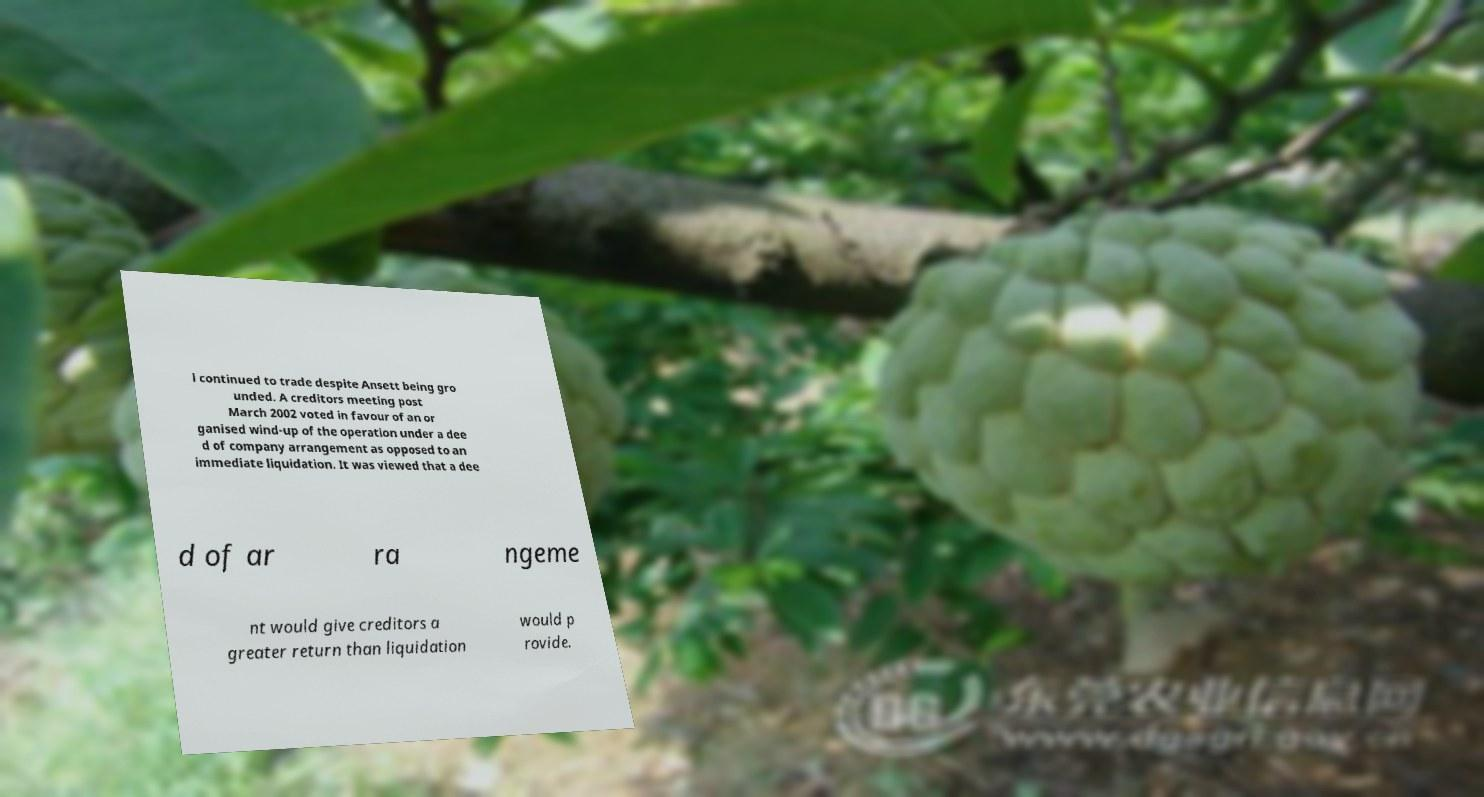For documentation purposes, I need the text within this image transcribed. Could you provide that? l continued to trade despite Ansett being gro unded. A creditors meeting post March 2002 voted in favour of an or ganised wind-up of the operation under a dee d of company arrangement as opposed to an immediate liquidation. It was viewed that a dee d of ar ra ngeme nt would give creditors a greater return than liquidation would p rovide. 